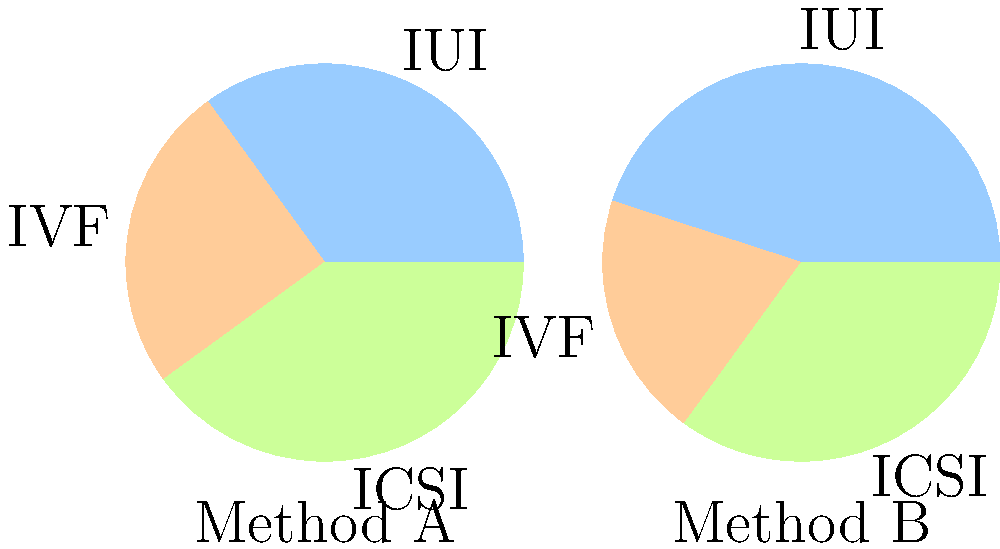The pie charts above show the success rates of different artificial insemination techniques for two different methods (A and B). Based on the information provided, which method shows a higher success rate for IUI (Intrauterine Insemination), and by how much? To answer this question, we need to compare the IUI success rates between Method A and Method B:

1. Identify IUI in both charts:
   - IUI is represented by the blue slice in both pie charts.

2. Compare the sizes of the blue slices:
   - In Method A, the blue slice appears to be 35% of the circle.
   - In Method B, the blue slice appears to be 45% of the circle.

3. Calculate the difference:
   $45\% - 35\% = 10\%$

4. Determine which method has the higher success rate:
   Method B has a larger blue slice, indicating a higher success rate for IUI.

Therefore, Method B shows a higher success rate for IUI, with a difference of 10 percentage points compared to Method A.
Answer: Method B, by 10% 